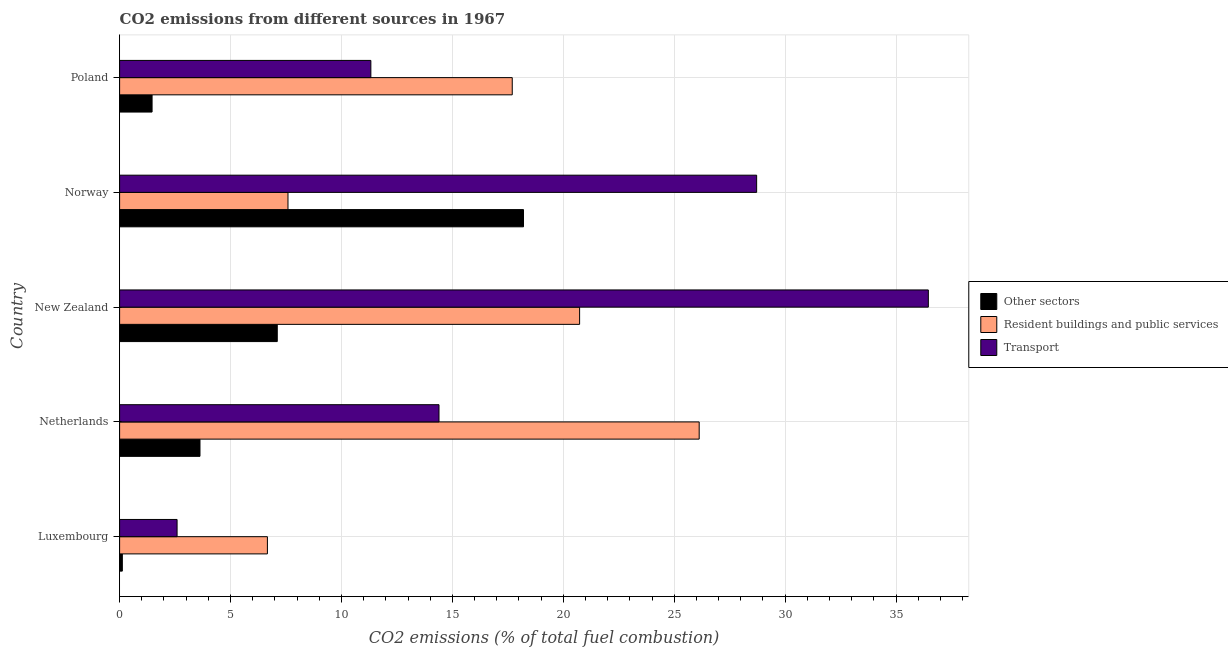How many groups of bars are there?
Keep it short and to the point. 5. Are the number of bars per tick equal to the number of legend labels?
Provide a succinct answer. Yes. Are the number of bars on each tick of the Y-axis equal?
Offer a terse response. Yes. How many bars are there on the 4th tick from the bottom?
Offer a very short reply. 3. What is the label of the 4th group of bars from the top?
Provide a succinct answer. Netherlands. In how many cases, is the number of bars for a given country not equal to the number of legend labels?
Your answer should be very brief. 0. What is the percentage of co2 emissions from transport in Netherlands?
Offer a very short reply. 14.4. Across all countries, what is the maximum percentage of co2 emissions from transport?
Offer a terse response. 36.45. Across all countries, what is the minimum percentage of co2 emissions from other sectors?
Keep it short and to the point. 0.12. In which country was the percentage of co2 emissions from resident buildings and public services minimum?
Make the answer very short. Luxembourg. What is the total percentage of co2 emissions from transport in the graph?
Ensure brevity in your answer.  93.48. What is the difference between the percentage of co2 emissions from transport in Norway and the percentage of co2 emissions from other sectors in Poland?
Your response must be concise. 27.25. What is the average percentage of co2 emissions from transport per country?
Provide a succinct answer. 18.7. What is the difference between the percentage of co2 emissions from transport and percentage of co2 emissions from other sectors in Luxembourg?
Keep it short and to the point. 2.47. In how many countries, is the percentage of co2 emissions from other sectors greater than 35 %?
Your response must be concise. 0. What is the ratio of the percentage of co2 emissions from transport in Luxembourg to that in Norway?
Ensure brevity in your answer.  0.09. Is the percentage of co2 emissions from other sectors in New Zealand less than that in Poland?
Ensure brevity in your answer.  No. What is the difference between the highest and the second highest percentage of co2 emissions from other sectors?
Offer a terse response. 11.1. What is the difference between the highest and the lowest percentage of co2 emissions from other sectors?
Offer a terse response. 18.08. In how many countries, is the percentage of co2 emissions from resident buildings and public services greater than the average percentage of co2 emissions from resident buildings and public services taken over all countries?
Offer a very short reply. 3. Is the sum of the percentage of co2 emissions from transport in Luxembourg and Poland greater than the maximum percentage of co2 emissions from other sectors across all countries?
Make the answer very short. No. What does the 3rd bar from the top in Luxembourg represents?
Your answer should be compact. Other sectors. What does the 1st bar from the bottom in New Zealand represents?
Provide a succinct answer. Other sectors. How many countries are there in the graph?
Keep it short and to the point. 5. What is the difference between two consecutive major ticks on the X-axis?
Your answer should be compact. 5. Are the values on the major ticks of X-axis written in scientific E-notation?
Offer a very short reply. No. Where does the legend appear in the graph?
Provide a short and direct response. Center right. How are the legend labels stacked?
Ensure brevity in your answer.  Vertical. What is the title of the graph?
Your answer should be very brief. CO2 emissions from different sources in 1967. What is the label or title of the X-axis?
Offer a very short reply. CO2 emissions (% of total fuel combustion). What is the CO2 emissions (% of total fuel combustion) in Other sectors in Luxembourg?
Your answer should be very brief. 0.12. What is the CO2 emissions (% of total fuel combustion) of Resident buildings and public services in Luxembourg?
Ensure brevity in your answer.  6.66. What is the CO2 emissions (% of total fuel combustion) in Transport in Luxembourg?
Your response must be concise. 2.59. What is the CO2 emissions (% of total fuel combustion) of Other sectors in Netherlands?
Your answer should be very brief. 3.62. What is the CO2 emissions (% of total fuel combustion) in Resident buildings and public services in Netherlands?
Your answer should be very brief. 26.13. What is the CO2 emissions (% of total fuel combustion) in Transport in Netherlands?
Offer a terse response. 14.4. What is the CO2 emissions (% of total fuel combustion) of Other sectors in New Zealand?
Keep it short and to the point. 7.11. What is the CO2 emissions (% of total fuel combustion) in Resident buildings and public services in New Zealand?
Your response must be concise. 20.74. What is the CO2 emissions (% of total fuel combustion) of Transport in New Zealand?
Your answer should be very brief. 36.45. What is the CO2 emissions (% of total fuel combustion) in Other sectors in Norway?
Offer a terse response. 18.21. What is the CO2 emissions (% of total fuel combustion) in Resident buildings and public services in Norway?
Offer a very short reply. 7.59. What is the CO2 emissions (% of total fuel combustion) in Transport in Norway?
Offer a terse response. 28.72. What is the CO2 emissions (% of total fuel combustion) of Other sectors in Poland?
Offer a very short reply. 1.46. What is the CO2 emissions (% of total fuel combustion) in Resident buildings and public services in Poland?
Your answer should be compact. 17.7. What is the CO2 emissions (% of total fuel combustion) in Transport in Poland?
Give a very brief answer. 11.33. Across all countries, what is the maximum CO2 emissions (% of total fuel combustion) of Other sectors?
Provide a short and direct response. 18.21. Across all countries, what is the maximum CO2 emissions (% of total fuel combustion) in Resident buildings and public services?
Provide a succinct answer. 26.13. Across all countries, what is the maximum CO2 emissions (% of total fuel combustion) of Transport?
Give a very brief answer. 36.45. Across all countries, what is the minimum CO2 emissions (% of total fuel combustion) of Other sectors?
Your response must be concise. 0.12. Across all countries, what is the minimum CO2 emissions (% of total fuel combustion) of Resident buildings and public services?
Offer a very short reply. 6.66. Across all countries, what is the minimum CO2 emissions (% of total fuel combustion) of Transport?
Give a very brief answer. 2.59. What is the total CO2 emissions (% of total fuel combustion) of Other sectors in the graph?
Ensure brevity in your answer.  30.52. What is the total CO2 emissions (% of total fuel combustion) of Resident buildings and public services in the graph?
Offer a very short reply. 78.81. What is the total CO2 emissions (% of total fuel combustion) in Transport in the graph?
Keep it short and to the point. 93.48. What is the difference between the CO2 emissions (% of total fuel combustion) in Other sectors in Luxembourg and that in Netherlands?
Your answer should be very brief. -3.5. What is the difference between the CO2 emissions (% of total fuel combustion) of Resident buildings and public services in Luxembourg and that in Netherlands?
Your answer should be compact. -19.46. What is the difference between the CO2 emissions (% of total fuel combustion) in Transport in Luxembourg and that in Netherlands?
Offer a very short reply. -11.81. What is the difference between the CO2 emissions (% of total fuel combustion) of Other sectors in Luxembourg and that in New Zealand?
Keep it short and to the point. -6.98. What is the difference between the CO2 emissions (% of total fuel combustion) in Resident buildings and public services in Luxembourg and that in New Zealand?
Offer a terse response. -14.07. What is the difference between the CO2 emissions (% of total fuel combustion) of Transport in Luxembourg and that in New Zealand?
Your answer should be very brief. -33.86. What is the difference between the CO2 emissions (% of total fuel combustion) in Other sectors in Luxembourg and that in Norway?
Your answer should be compact. -18.08. What is the difference between the CO2 emissions (% of total fuel combustion) in Resident buildings and public services in Luxembourg and that in Norway?
Your answer should be compact. -0.93. What is the difference between the CO2 emissions (% of total fuel combustion) of Transport in Luxembourg and that in Norway?
Provide a short and direct response. -26.12. What is the difference between the CO2 emissions (% of total fuel combustion) of Other sectors in Luxembourg and that in Poland?
Make the answer very short. -1.34. What is the difference between the CO2 emissions (% of total fuel combustion) of Resident buildings and public services in Luxembourg and that in Poland?
Offer a very short reply. -11.04. What is the difference between the CO2 emissions (% of total fuel combustion) in Transport in Luxembourg and that in Poland?
Give a very brief answer. -8.73. What is the difference between the CO2 emissions (% of total fuel combustion) of Other sectors in Netherlands and that in New Zealand?
Ensure brevity in your answer.  -3.48. What is the difference between the CO2 emissions (% of total fuel combustion) in Resident buildings and public services in Netherlands and that in New Zealand?
Keep it short and to the point. 5.39. What is the difference between the CO2 emissions (% of total fuel combustion) of Transport in Netherlands and that in New Zealand?
Your answer should be compact. -22.06. What is the difference between the CO2 emissions (% of total fuel combustion) in Other sectors in Netherlands and that in Norway?
Offer a very short reply. -14.58. What is the difference between the CO2 emissions (% of total fuel combustion) of Resident buildings and public services in Netherlands and that in Norway?
Offer a very short reply. 18.54. What is the difference between the CO2 emissions (% of total fuel combustion) in Transport in Netherlands and that in Norway?
Your answer should be very brief. -14.32. What is the difference between the CO2 emissions (% of total fuel combustion) in Other sectors in Netherlands and that in Poland?
Provide a short and direct response. 2.16. What is the difference between the CO2 emissions (% of total fuel combustion) of Resident buildings and public services in Netherlands and that in Poland?
Your answer should be compact. 8.43. What is the difference between the CO2 emissions (% of total fuel combustion) of Transport in Netherlands and that in Poland?
Your answer should be compact. 3.07. What is the difference between the CO2 emissions (% of total fuel combustion) of Other sectors in New Zealand and that in Norway?
Provide a short and direct response. -11.1. What is the difference between the CO2 emissions (% of total fuel combustion) of Resident buildings and public services in New Zealand and that in Norway?
Your answer should be very brief. 13.15. What is the difference between the CO2 emissions (% of total fuel combustion) of Transport in New Zealand and that in Norway?
Give a very brief answer. 7.74. What is the difference between the CO2 emissions (% of total fuel combustion) of Other sectors in New Zealand and that in Poland?
Offer a very short reply. 5.64. What is the difference between the CO2 emissions (% of total fuel combustion) of Resident buildings and public services in New Zealand and that in Poland?
Provide a succinct answer. 3.04. What is the difference between the CO2 emissions (% of total fuel combustion) in Transport in New Zealand and that in Poland?
Keep it short and to the point. 25.13. What is the difference between the CO2 emissions (% of total fuel combustion) of Other sectors in Norway and that in Poland?
Your response must be concise. 16.74. What is the difference between the CO2 emissions (% of total fuel combustion) of Resident buildings and public services in Norway and that in Poland?
Keep it short and to the point. -10.11. What is the difference between the CO2 emissions (% of total fuel combustion) of Transport in Norway and that in Poland?
Your answer should be compact. 17.39. What is the difference between the CO2 emissions (% of total fuel combustion) in Other sectors in Luxembourg and the CO2 emissions (% of total fuel combustion) in Resident buildings and public services in Netherlands?
Provide a succinct answer. -26. What is the difference between the CO2 emissions (% of total fuel combustion) in Other sectors in Luxembourg and the CO2 emissions (% of total fuel combustion) in Transport in Netherlands?
Keep it short and to the point. -14.27. What is the difference between the CO2 emissions (% of total fuel combustion) in Resident buildings and public services in Luxembourg and the CO2 emissions (% of total fuel combustion) in Transport in Netherlands?
Give a very brief answer. -7.74. What is the difference between the CO2 emissions (% of total fuel combustion) in Other sectors in Luxembourg and the CO2 emissions (% of total fuel combustion) in Resident buildings and public services in New Zealand?
Keep it short and to the point. -20.61. What is the difference between the CO2 emissions (% of total fuel combustion) in Other sectors in Luxembourg and the CO2 emissions (% of total fuel combustion) in Transport in New Zealand?
Offer a terse response. -36.33. What is the difference between the CO2 emissions (% of total fuel combustion) in Resident buildings and public services in Luxembourg and the CO2 emissions (% of total fuel combustion) in Transport in New Zealand?
Offer a terse response. -29.79. What is the difference between the CO2 emissions (% of total fuel combustion) of Other sectors in Luxembourg and the CO2 emissions (% of total fuel combustion) of Resident buildings and public services in Norway?
Your answer should be compact. -7.47. What is the difference between the CO2 emissions (% of total fuel combustion) in Other sectors in Luxembourg and the CO2 emissions (% of total fuel combustion) in Transport in Norway?
Offer a terse response. -28.59. What is the difference between the CO2 emissions (% of total fuel combustion) of Resident buildings and public services in Luxembourg and the CO2 emissions (% of total fuel combustion) of Transport in Norway?
Offer a very short reply. -22.05. What is the difference between the CO2 emissions (% of total fuel combustion) in Other sectors in Luxembourg and the CO2 emissions (% of total fuel combustion) in Resident buildings and public services in Poland?
Your response must be concise. -17.58. What is the difference between the CO2 emissions (% of total fuel combustion) in Other sectors in Luxembourg and the CO2 emissions (% of total fuel combustion) in Transport in Poland?
Your answer should be very brief. -11.2. What is the difference between the CO2 emissions (% of total fuel combustion) in Resident buildings and public services in Luxembourg and the CO2 emissions (% of total fuel combustion) in Transport in Poland?
Keep it short and to the point. -4.66. What is the difference between the CO2 emissions (% of total fuel combustion) of Other sectors in Netherlands and the CO2 emissions (% of total fuel combustion) of Resident buildings and public services in New Zealand?
Provide a short and direct response. -17.11. What is the difference between the CO2 emissions (% of total fuel combustion) of Other sectors in Netherlands and the CO2 emissions (% of total fuel combustion) of Transport in New Zealand?
Offer a very short reply. -32.83. What is the difference between the CO2 emissions (% of total fuel combustion) in Resident buildings and public services in Netherlands and the CO2 emissions (% of total fuel combustion) in Transport in New Zealand?
Provide a succinct answer. -10.33. What is the difference between the CO2 emissions (% of total fuel combustion) of Other sectors in Netherlands and the CO2 emissions (% of total fuel combustion) of Resident buildings and public services in Norway?
Your response must be concise. -3.97. What is the difference between the CO2 emissions (% of total fuel combustion) in Other sectors in Netherlands and the CO2 emissions (% of total fuel combustion) in Transport in Norway?
Make the answer very short. -25.09. What is the difference between the CO2 emissions (% of total fuel combustion) of Resident buildings and public services in Netherlands and the CO2 emissions (% of total fuel combustion) of Transport in Norway?
Your response must be concise. -2.59. What is the difference between the CO2 emissions (% of total fuel combustion) in Other sectors in Netherlands and the CO2 emissions (% of total fuel combustion) in Resident buildings and public services in Poland?
Ensure brevity in your answer.  -14.08. What is the difference between the CO2 emissions (% of total fuel combustion) in Other sectors in Netherlands and the CO2 emissions (% of total fuel combustion) in Transport in Poland?
Make the answer very short. -7.7. What is the difference between the CO2 emissions (% of total fuel combustion) in Resident buildings and public services in Netherlands and the CO2 emissions (% of total fuel combustion) in Transport in Poland?
Offer a very short reply. 14.8. What is the difference between the CO2 emissions (% of total fuel combustion) of Other sectors in New Zealand and the CO2 emissions (% of total fuel combustion) of Resident buildings and public services in Norway?
Your response must be concise. -0.48. What is the difference between the CO2 emissions (% of total fuel combustion) in Other sectors in New Zealand and the CO2 emissions (% of total fuel combustion) in Transport in Norway?
Give a very brief answer. -21.61. What is the difference between the CO2 emissions (% of total fuel combustion) of Resident buildings and public services in New Zealand and the CO2 emissions (% of total fuel combustion) of Transport in Norway?
Offer a terse response. -7.98. What is the difference between the CO2 emissions (% of total fuel combustion) of Other sectors in New Zealand and the CO2 emissions (% of total fuel combustion) of Resident buildings and public services in Poland?
Provide a succinct answer. -10.59. What is the difference between the CO2 emissions (% of total fuel combustion) of Other sectors in New Zealand and the CO2 emissions (% of total fuel combustion) of Transport in Poland?
Provide a short and direct response. -4.22. What is the difference between the CO2 emissions (% of total fuel combustion) of Resident buildings and public services in New Zealand and the CO2 emissions (% of total fuel combustion) of Transport in Poland?
Ensure brevity in your answer.  9.41. What is the difference between the CO2 emissions (% of total fuel combustion) in Other sectors in Norway and the CO2 emissions (% of total fuel combustion) in Resident buildings and public services in Poland?
Offer a terse response. 0.51. What is the difference between the CO2 emissions (% of total fuel combustion) in Other sectors in Norway and the CO2 emissions (% of total fuel combustion) in Transport in Poland?
Provide a short and direct response. 6.88. What is the difference between the CO2 emissions (% of total fuel combustion) of Resident buildings and public services in Norway and the CO2 emissions (% of total fuel combustion) of Transport in Poland?
Ensure brevity in your answer.  -3.74. What is the average CO2 emissions (% of total fuel combustion) of Other sectors per country?
Offer a very short reply. 6.1. What is the average CO2 emissions (% of total fuel combustion) in Resident buildings and public services per country?
Make the answer very short. 15.76. What is the average CO2 emissions (% of total fuel combustion) in Transport per country?
Offer a very short reply. 18.7. What is the difference between the CO2 emissions (% of total fuel combustion) of Other sectors and CO2 emissions (% of total fuel combustion) of Resident buildings and public services in Luxembourg?
Your answer should be very brief. -6.54. What is the difference between the CO2 emissions (% of total fuel combustion) in Other sectors and CO2 emissions (% of total fuel combustion) in Transport in Luxembourg?
Your answer should be compact. -2.47. What is the difference between the CO2 emissions (% of total fuel combustion) in Resident buildings and public services and CO2 emissions (% of total fuel combustion) in Transport in Luxembourg?
Offer a terse response. 4.07. What is the difference between the CO2 emissions (% of total fuel combustion) of Other sectors and CO2 emissions (% of total fuel combustion) of Resident buildings and public services in Netherlands?
Offer a very short reply. -22.5. What is the difference between the CO2 emissions (% of total fuel combustion) of Other sectors and CO2 emissions (% of total fuel combustion) of Transport in Netherlands?
Provide a short and direct response. -10.77. What is the difference between the CO2 emissions (% of total fuel combustion) of Resident buildings and public services and CO2 emissions (% of total fuel combustion) of Transport in Netherlands?
Your answer should be very brief. 11.73. What is the difference between the CO2 emissions (% of total fuel combustion) in Other sectors and CO2 emissions (% of total fuel combustion) in Resident buildings and public services in New Zealand?
Your answer should be compact. -13.63. What is the difference between the CO2 emissions (% of total fuel combustion) of Other sectors and CO2 emissions (% of total fuel combustion) of Transport in New Zealand?
Make the answer very short. -29.35. What is the difference between the CO2 emissions (% of total fuel combustion) in Resident buildings and public services and CO2 emissions (% of total fuel combustion) in Transport in New Zealand?
Provide a short and direct response. -15.72. What is the difference between the CO2 emissions (% of total fuel combustion) of Other sectors and CO2 emissions (% of total fuel combustion) of Resident buildings and public services in Norway?
Provide a short and direct response. 10.62. What is the difference between the CO2 emissions (% of total fuel combustion) in Other sectors and CO2 emissions (% of total fuel combustion) in Transport in Norway?
Your answer should be compact. -10.51. What is the difference between the CO2 emissions (% of total fuel combustion) of Resident buildings and public services and CO2 emissions (% of total fuel combustion) of Transport in Norway?
Provide a short and direct response. -21.13. What is the difference between the CO2 emissions (% of total fuel combustion) in Other sectors and CO2 emissions (% of total fuel combustion) in Resident buildings and public services in Poland?
Offer a terse response. -16.24. What is the difference between the CO2 emissions (% of total fuel combustion) of Other sectors and CO2 emissions (% of total fuel combustion) of Transport in Poland?
Your response must be concise. -9.86. What is the difference between the CO2 emissions (% of total fuel combustion) in Resident buildings and public services and CO2 emissions (% of total fuel combustion) in Transport in Poland?
Ensure brevity in your answer.  6.37. What is the ratio of the CO2 emissions (% of total fuel combustion) in Other sectors in Luxembourg to that in Netherlands?
Ensure brevity in your answer.  0.03. What is the ratio of the CO2 emissions (% of total fuel combustion) in Resident buildings and public services in Luxembourg to that in Netherlands?
Your answer should be very brief. 0.26. What is the ratio of the CO2 emissions (% of total fuel combustion) in Transport in Luxembourg to that in Netherlands?
Offer a terse response. 0.18. What is the ratio of the CO2 emissions (% of total fuel combustion) of Other sectors in Luxembourg to that in New Zealand?
Offer a terse response. 0.02. What is the ratio of the CO2 emissions (% of total fuel combustion) in Resident buildings and public services in Luxembourg to that in New Zealand?
Provide a short and direct response. 0.32. What is the ratio of the CO2 emissions (% of total fuel combustion) of Transport in Luxembourg to that in New Zealand?
Your response must be concise. 0.07. What is the ratio of the CO2 emissions (% of total fuel combustion) in Other sectors in Luxembourg to that in Norway?
Offer a very short reply. 0.01. What is the ratio of the CO2 emissions (% of total fuel combustion) of Resident buildings and public services in Luxembourg to that in Norway?
Make the answer very short. 0.88. What is the ratio of the CO2 emissions (% of total fuel combustion) of Transport in Luxembourg to that in Norway?
Offer a very short reply. 0.09. What is the ratio of the CO2 emissions (% of total fuel combustion) of Other sectors in Luxembourg to that in Poland?
Your response must be concise. 0.08. What is the ratio of the CO2 emissions (% of total fuel combustion) of Resident buildings and public services in Luxembourg to that in Poland?
Keep it short and to the point. 0.38. What is the ratio of the CO2 emissions (% of total fuel combustion) in Transport in Luxembourg to that in Poland?
Your answer should be very brief. 0.23. What is the ratio of the CO2 emissions (% of total fuel combustion) of Other sectors in Netherlands to that in New Zealand?
Make the answer very short. 0.51. What is the ratio of the CO2 emissions (% of total fuel combustion) in Resident buildings and public services in Netherlands to that in New Zealand?
Your response must be concise. 1.26. What is the ratio of the CO2 emissions (% of total fuel combustion) in Transport in Netherlands to that in New Zealand?
Give a very brief answer. 0.39. What is the ratio of the CO2 emissions (% of total fuel combustion) of Other sectors in Netherlands to that in Norway?
Provide a short and direct response. 0.2. What is the ratio of the CO2 emissions (% of total fuel combustion) of Resident buildings and public services in Netherlands to that in Norway?
Your response must be concise. 3.44. What is the ratio of the CO2 emissions (% of total fuel combustion) in Transport in Netherlands to that in Norway?
Offer a terse response. 0.5. What is the ratio of the CO2 emissions (% of total fuel combustion) of Other sectors in Netherlands to that in Poland?
Offer a very short reply. 2.48. What is the ratio of the CO2 emissions (% of total fuel combustion) in Resident buildings and public services in Netherlands to that in Poland?
Make the answer very short. 1.48. What is the ratio of the CO2 emissions (% of total fuel combustion) of Transport in Netherlands to that in Poland?
Offer a very short reply. 1.27. What is the ratio of the CO2 emissions (% of total fuel combustion) of Other sectors in New Zealand to that in Norway?
Your answer should be very brief. 0.39. What is the ratio of the CO2 emissions (% of total fuel combustion) of Resident buildings and public services in New Zealand to that in Norway?
Offer a terse response. 2.73. What is the ratio of the CO2 emissions (% of total fuel combustion) of Transport in New Zealand to that in Norway?
Your answer should be compact. 1.27. What is the ratio of the CO2 emissions (% of total fuel combustion) of Other sectors in New Zealand to that in Poland?
Keep it short and to the point. 4.86. What is the ratio of the CO2 emissions (% of total fuel combustion) of Resident buildings and public services in New Zealand to that in Poland?
Keep it short and to the point. 1.17. What is the ratio of the CO2 emissions (% of total fuel combustion) in Transport in New Zealand to that in Poland?
Keep it short and to the point. 3.22. What is the ratio of the CO2 emissions (% of total fuel combustion) in Other sectors in Norway to that in Poland?
Ensure brevity in your answer.  12.44. What is the ratio of the CO2 emissions (% of total fuel combustion) of Resident buildings and public services in Norway to that in Poland?
Provide a short and direct response. 0.43. What is the ratio of the CO2 emissions (% of total fuel combustion) of Transport in Norway to that in Poland?
Offer a very short reply. 2.54. What is the difference between the highest and the second highest CO2 emissions (% of total fuel combustion) in Other sectors?
Your response must be concise. 11.1. What is the difference between the highest and the second highest CO2 emissions (% of total fuel combustion) of Resident buildings and public services?
Provide a short and direct response. 5.39. What is the difference between the highest and the second highest CO2 emissions (% of total fuel combustion) of Transport?
Ensure brevity in your answer.  7.74. What is the difference between the highest and the lowest CO2 emissions (% of total fuel combustion) of Other sectors?
Ensure brevity in your answer.  18.08. What is the difference between the highest and the lowest CO2 emissions (% of total fuel combustion) in Resident buildings and public services?
Offer a terse response. 19.46. What is the difference between the highest and the lowest CO2 emissions (% of total fuel combustion) of Transport?
Ensure brevity in your answer.  33.86. 